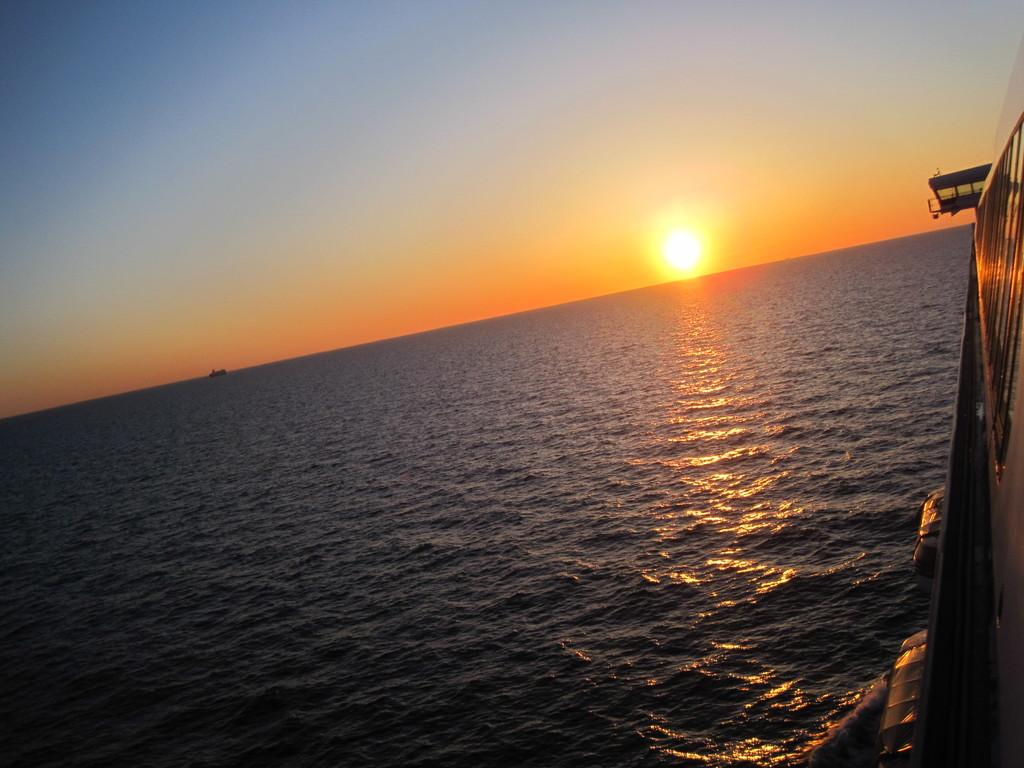What is located at the bottom of the image? There is an ocean at the bottom of the image. What can be seen on the right side of the image? There is a boat on the right side of the image. What is visible at the top of the image? The sky is visible at the top of the image. What celestial body is present in the center of the image? The sun is present in the center of the image. Can you see any veins in the image? There are no veins present in the image; it features an ocean, a boat, the sky, and the sun. What type of pickle is floating in the ocean in the image? There is no pickle present in the image; it features an ocean, a boat, the sky, and the sun. 